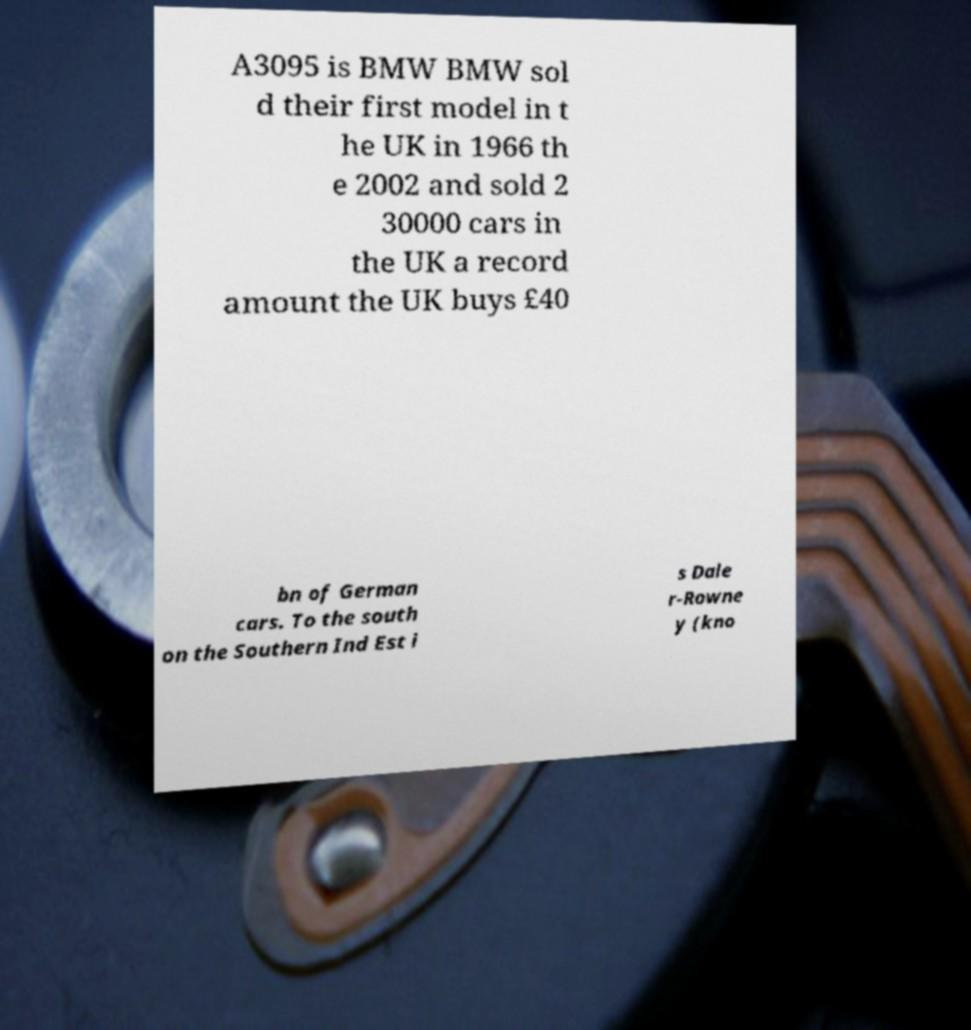There's text embedded in this image that I need extracted. Can you transcribe it verbatim? A3095 is BMW BMW sol d their first model in t he UK in 1966 th e 2002 and sold 2 30000 cars in the UK a record amount the UK buys £40 bn of German cars. To the south on the Southern Ind Est i s Dale r-Rowne y (kno 